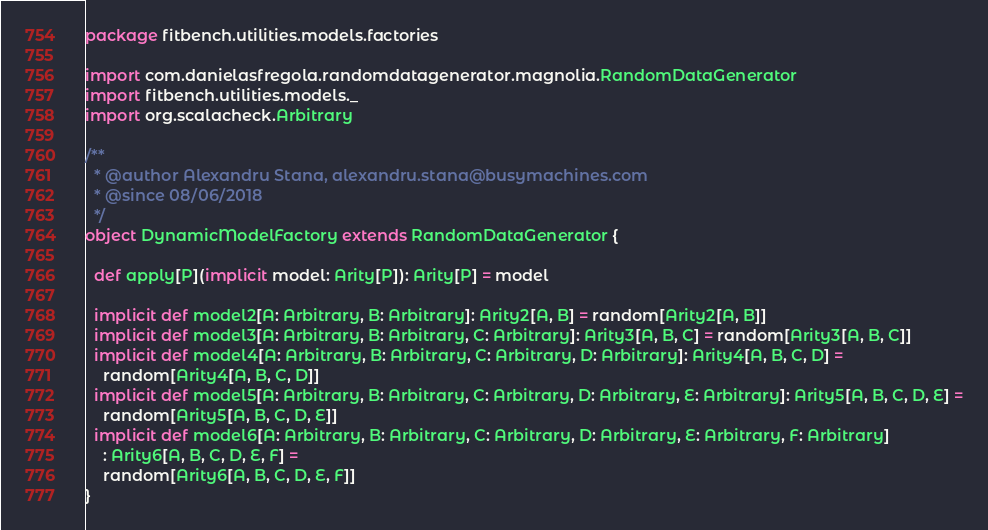Convert code to text. <code><loc_0><loc_0><loc_500><loc_500><_Scala_>package fitbench.utilities.models.factories

import com.danielasfregola.randomdatagenerator.magnolia.RandomDataGenerator
import fitbench.utilities.models._
import org.scalacheck.Arbitrary

/**
  * @author Alexandru Stana, alexandru.stana@busymachines.com
  * @since 08/06/2018
  */
object DynamicModelFactory extends RandomDataGenerator {

  def apply[P](implicit model: Arity[P]): Arity[P] = model

  implicit def model2[A: Arbitrary, B: Arbitrary]: Arity2[A, B] = random[Arity2[A, B]]
  implicit def model3[A: Arbitrary, B: Arbitrary, C: Arbitrary]: Arity3[A, B, C] = random[Arity3[A, B, C]]
  implicit def model4[A: Arbitrary, B: Arbitrary, C: Arbitrary, D: Arbitrary]: Arity4[A, B, C, D] =
    random[Arity4[A, B, C, D]]
  implicit def model5[A: Arbitrary, B: Arbitrary, C: Arbitrary, D: Arbitrary, E: Arbitrary]: Arity5[A, B, C, D, E] =
    random[Arity5[A, B, C, D, E]]
  implicit def model6[A: Arbitrary, B: Arbitrary, C: Arbitrary, D: Arbitrary, E: Arbitrary, F: Arbitrary]
    : Arity6[A, B, C, D, E, F] =
    random[Arity6[A, B, C, D, E, F]]
}
</code> 